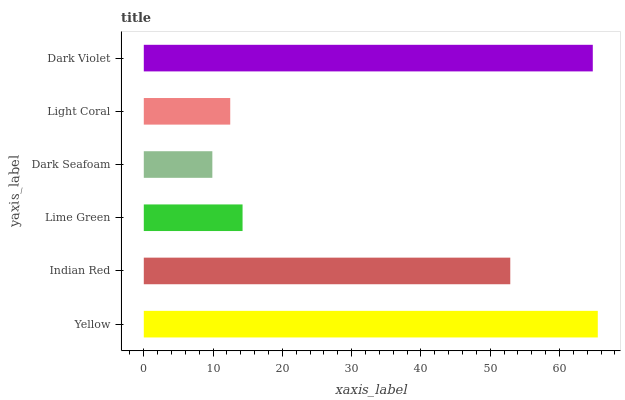Is Dark Seafoam the minimum?
Answer yes or no. Yes. Is Yellow the maximum?
Answer yes or no. Yes. Is Indian Red the minimum?
Answer yes or no. No. Is Indian Red the maximum?
Answer yes or no. No. Is Yellow greater than Indian Red?
Answer yes or no. Yes. Is Indian Red less than Yellow?
Answer yes or no. Yes. Is Indian Red greater than Yellow?
Answer yes or no. No. Is Yellow less than Indian Red?
Answer yes or no. No. Is Indian Red the high median?
Answer yes or no. Yes. Is Lime Green the low median?
Answer yes or no. Yes. Is Lime Green the high median?
Answer yes or no. No. Is Dark Violet the low median?
Answer yes or no. No. 